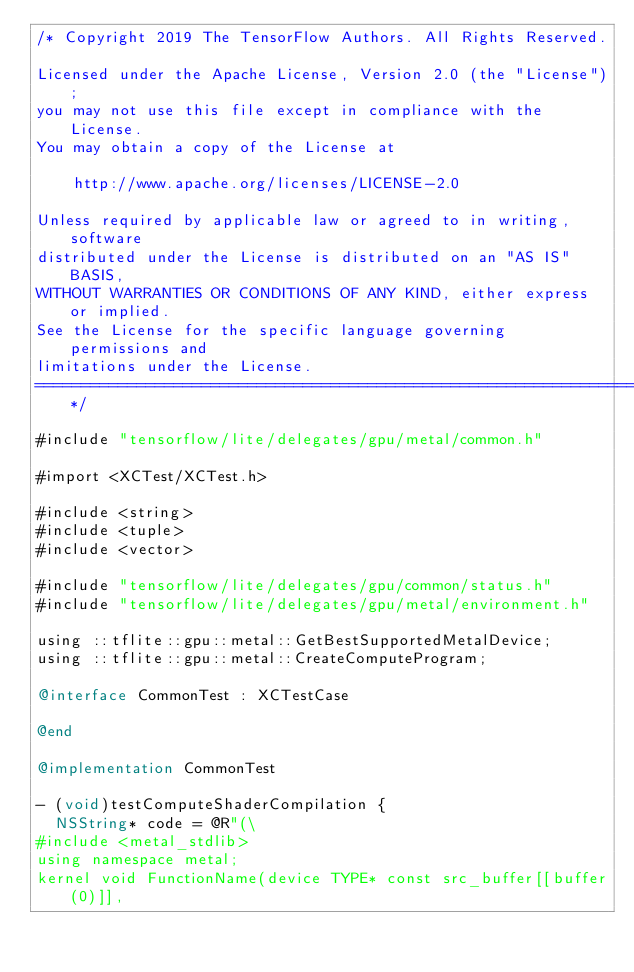<code> <loc_0><loc_0><loc_500><loc_500><_ObjectiveC_>/* Copyright 2019 The TensorFlow Authors. All Rights Reserved.

Licensed under the Apache License, Version 2.0 (the "License");
you may not use this file except in compliance with the License.
You may obtain a copy of the License at

    http://www.apache.org/licenses/LICENSE-2.0

Unless required by applicable law or agreed to in writing, software
distributed under the License is distributed on an "AS IS" BASIS,
WITHOUT WARRANTIES OR CONDITIONS OF ANY KIND, either express or implied.
See the License for the specific language governing permissions and
limitations under the License.
==============================================================================*/

#include "tensorflow/lite/delegates/gpu/metal/common.h"

#import <XCTest/XCTest.h>

#include <string>
#include <tuple>
#include <vector>

#include "tensorflow/lite/delegates/gpu/common/status.h"
#include "tensorflow/lite/delegates/gpu/metal/environment.h"

using ::tflite::gpu::metal::GetBestSupportedMetalDevice;
using ::tflite::gpu::metal::CreateComputeProgram;

@interface CommonTest : XCTestCase

@end

@implementation CommonTest

- (void)testComputeShaderCompilation {
  NSString* code = @R"(\
#include <metal_stdlib>
using namespace metal;
kernel void FunctionName(device TYPE* const src_buffer[[buffer(0)]],</code> 